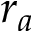<formula> <loc_0><loc_0><loc_500><loc_500>r _ { a }</formula> 